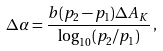<formula> <loc_0><loc_0><loc_500><loc_500>\Delta \alpha = \frac { b ( p _ { 2 } - p _ { 1 } ) \Delta A _ { K } } { \log _ { 1 0 } ( p _ { 2 } / p _ { 1 } ) } \, ,</formula> 